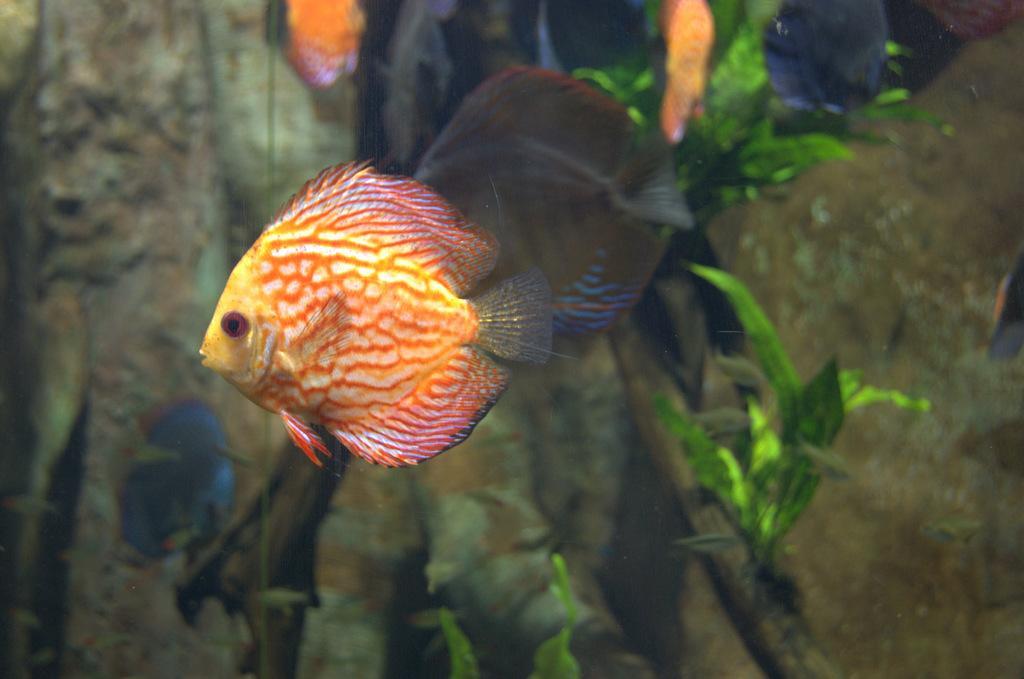Could you give a brief overview of what you see in this image? In the picture there are many fishes present, there are plants. 